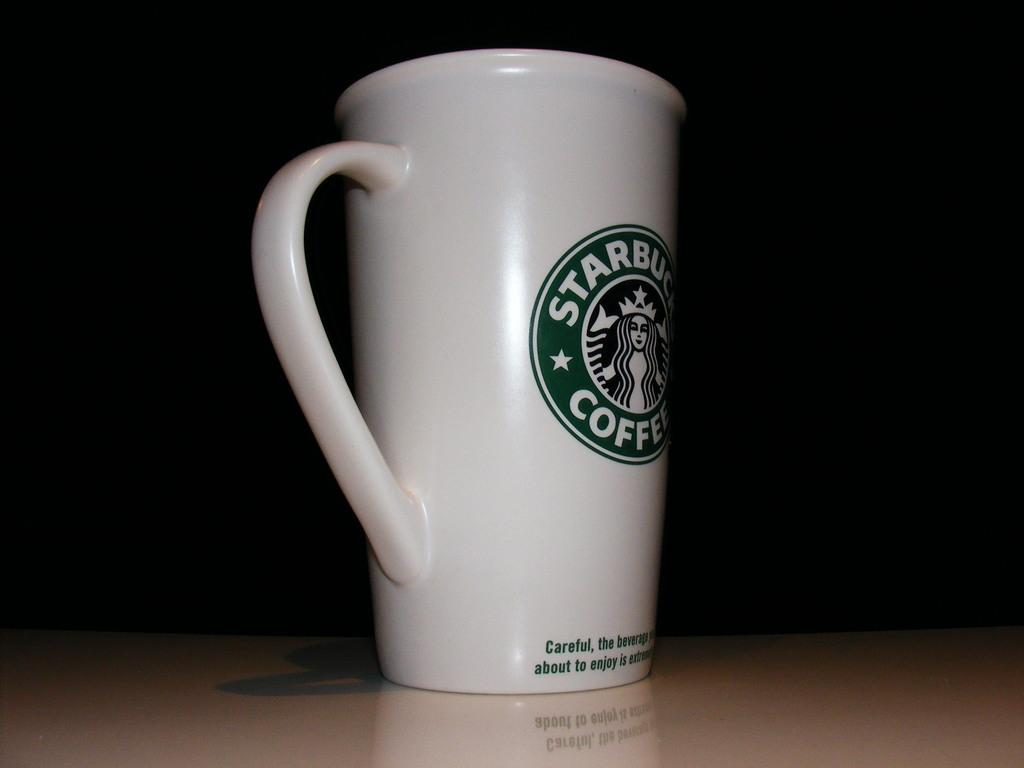<image>
Offer a succinct explanation of the picture presented. A white coffee mug with the Starbucks logo on the cup 